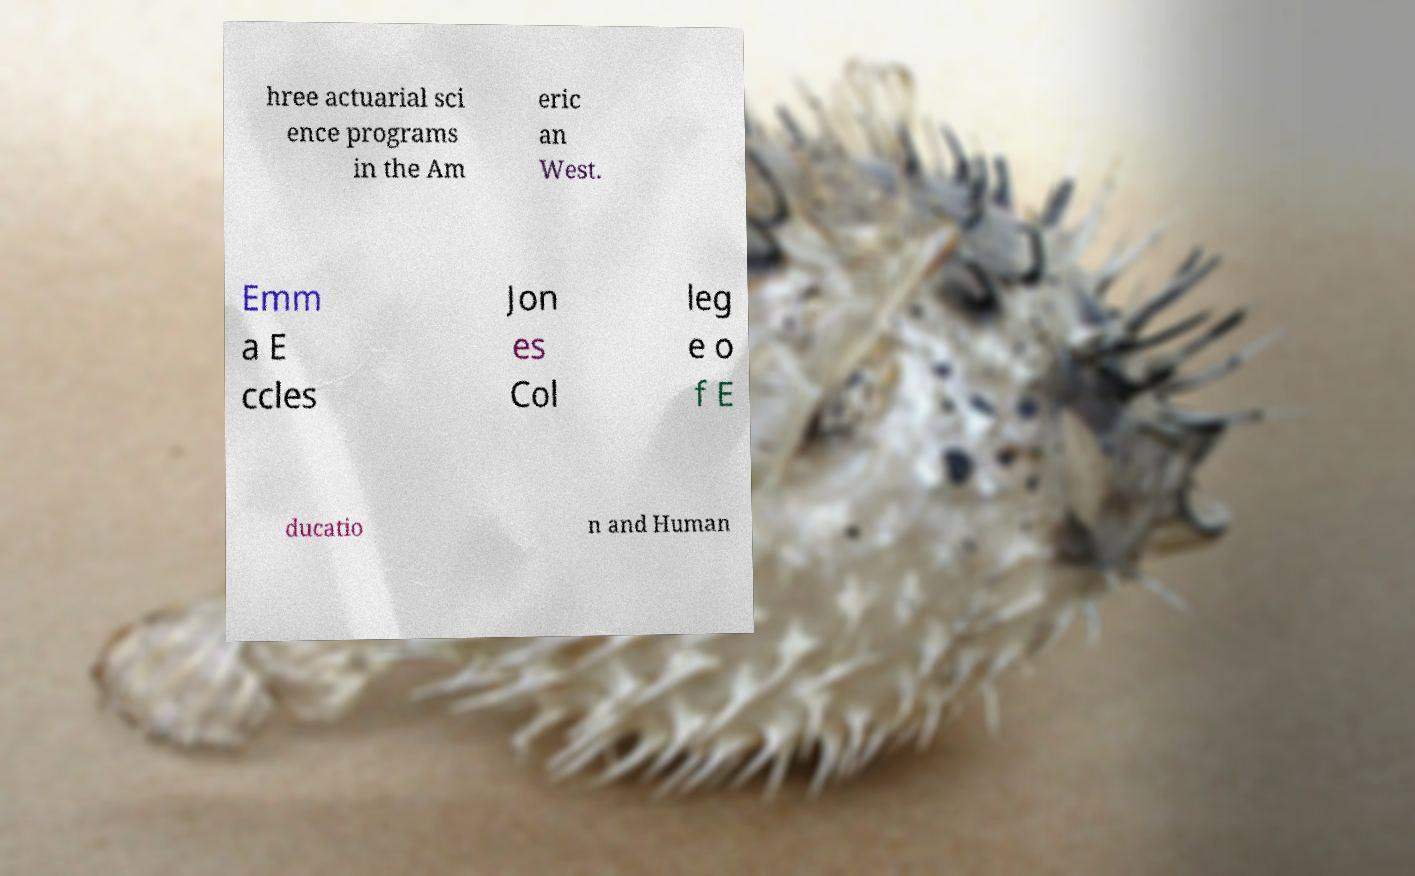Please read and relay the text visible in this image. What does it say? hree actuarial sci ence programs in the Am eric an West. Emm a E ccles Jon es Col leg e o f E ducatio n and Human 